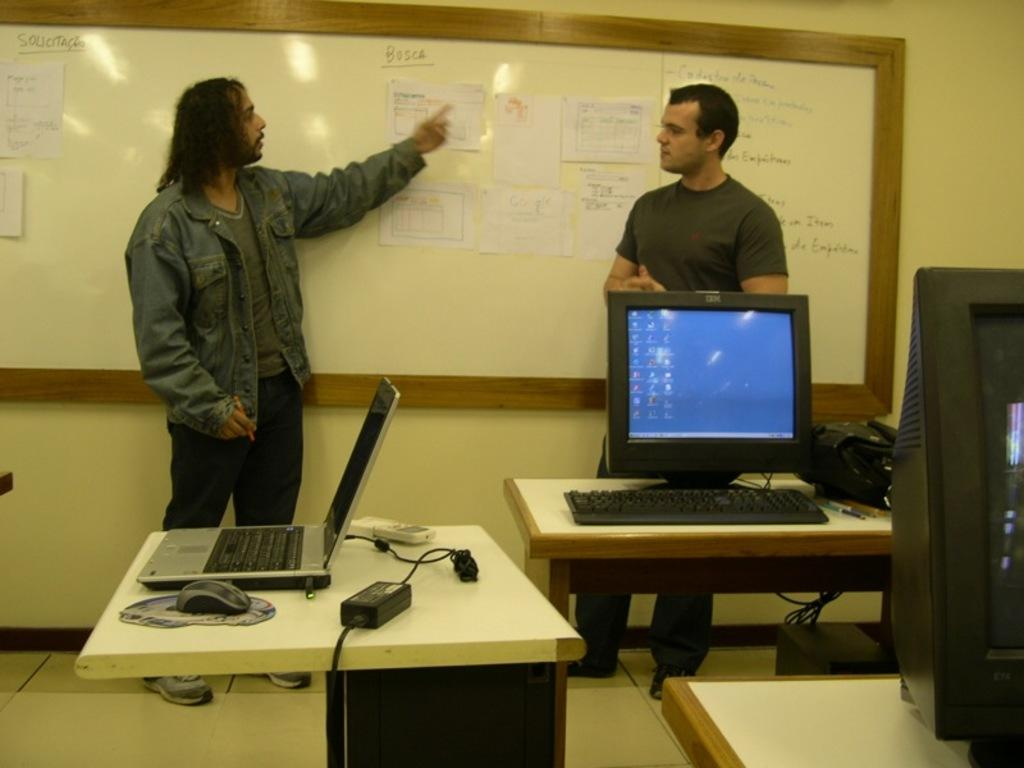How many people are in the image? There are two men standing in the image. What objects are present in the image that might be used for work or study? A laptop, monitor, and keyboard are visible in the image. Can you describe the setting in which the men are standing? The presence of multiple tables suggests that the men are in a workspace or study area. What types of pets are visible in the image? There are no pets present in the image. How does the society depicted in the image function? The image does not depict a society, so it is not possible to determine how it functions. 